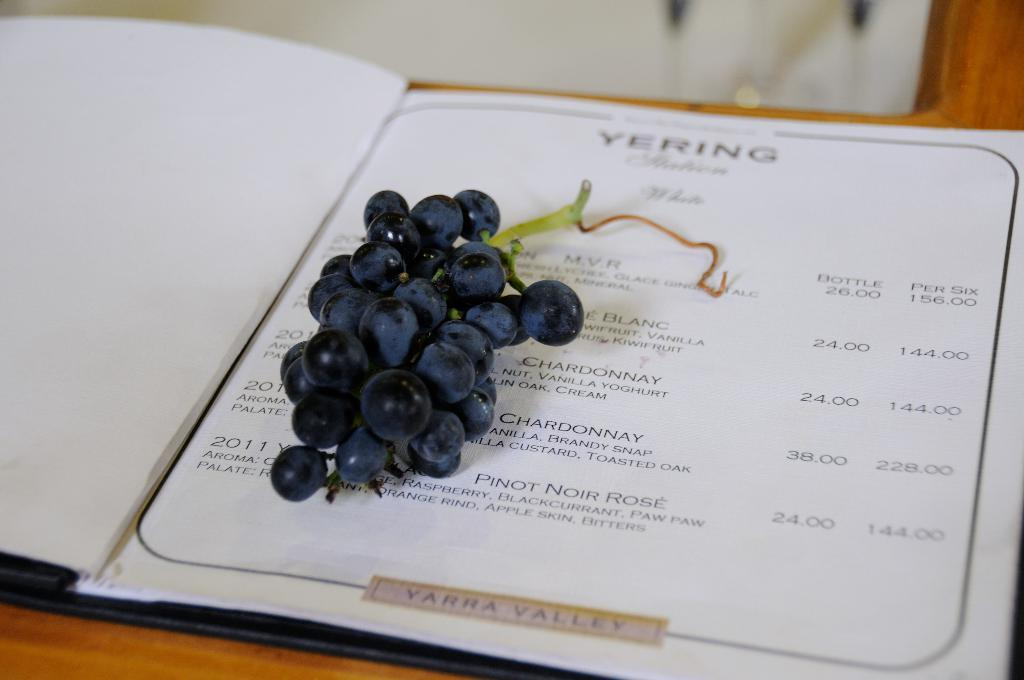What is the main object in the image? There is a menu card in the image. Where is the menu card located? The menu card is on a table. What is depicted on the menu card? There is a bunch of grapes on the menu card. What type of circle is used to represent a quiver in the image? There is no circle or quiver present in the image; it features a menu card with a bunch of grapes. Is there any evidence of a battle taking place in the image? There is no battle or any related elements present in the image; it features a menu card with a bunch of grapes. 